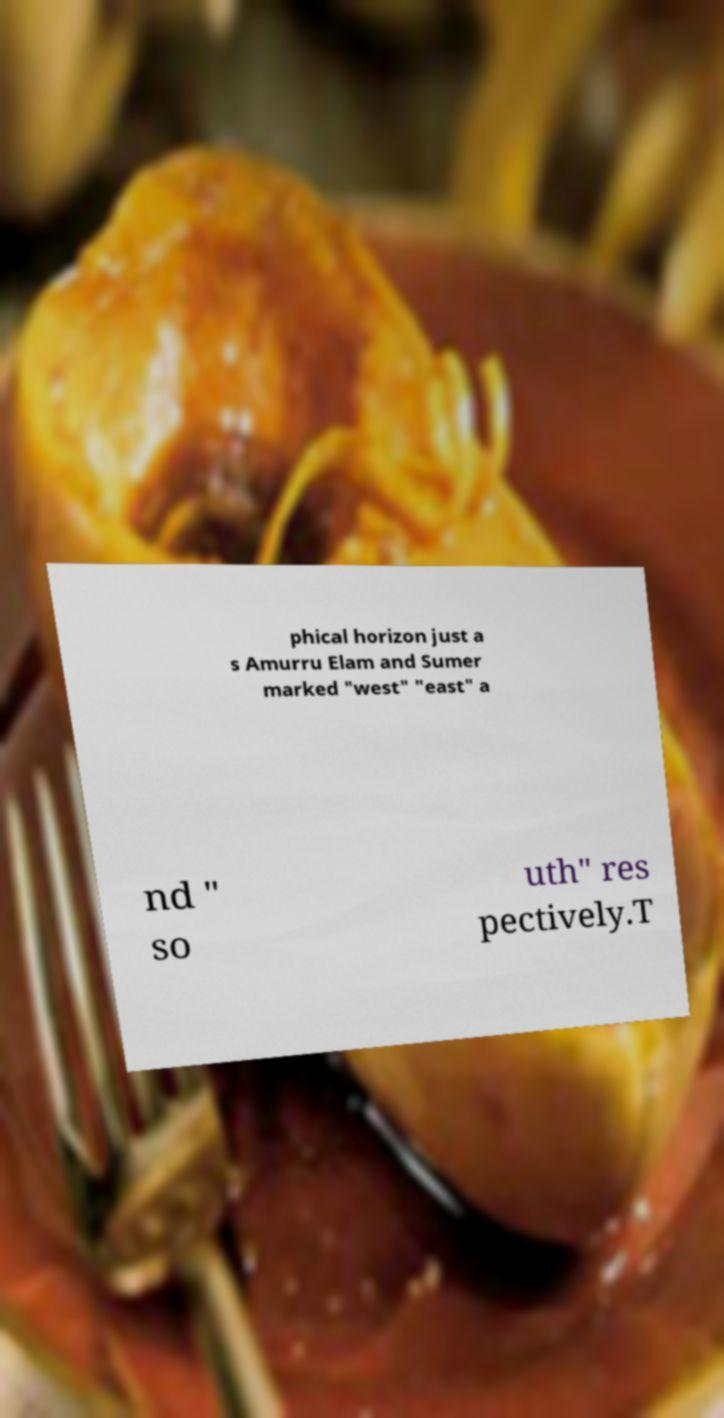Can you accurately transcribe the text from the provided image for me? phical horizon just a s Amurru Elam and Sumer marked "west" "east" a nd " so uth" res pectively.T 